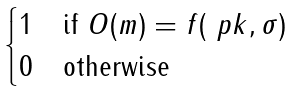Convert formula to latex. <formula><loc_0><loc_0><loc_500><loc_500>\begin{cases} 1 & \text {if } O ( m ) = f ( \ p k , \sigma ) \\ 0 & \text {otherwise} \end{cases}</formula> 